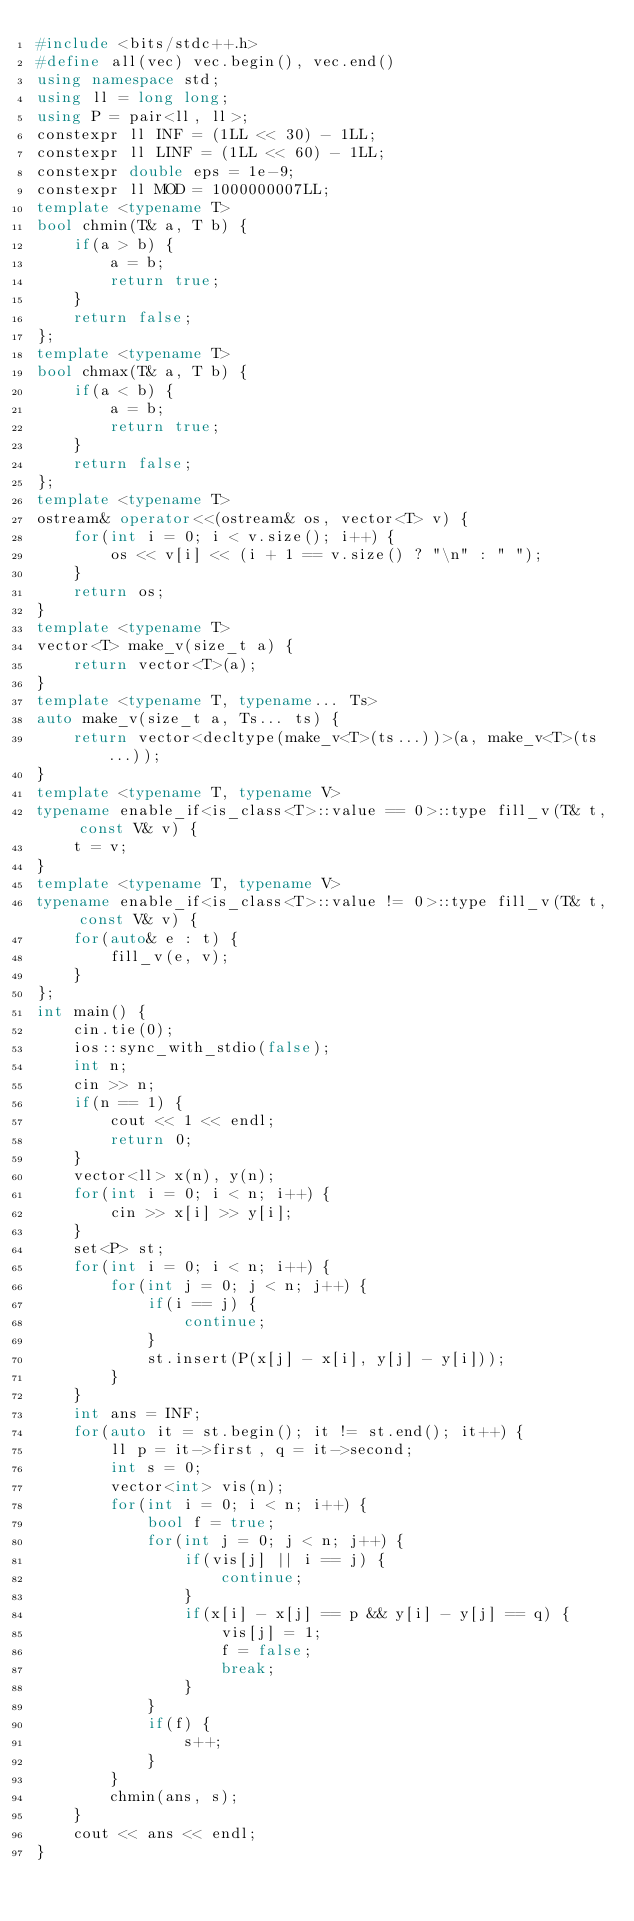Convert code to text. <code><loc_0><loc_0><loc_500><loc_500><_C++_>#include <bits/stdc++.h>
#define all(vec) vec.begin(), vec.end()
using namespace std;
using ll = long long;
using P = pair<ll, ll>;
constexpr ll INF = (1LL << 30) - 1LL;
constexpr ll LINF = (1LL << 60) - 1LL;
constexpr double eps = 1e-9;
constexpr ll MOD = 1000000007LL;
template <typename T>
bool chmin(T& a, T b) {
    if(a > b) {
        a = b;
        return true;
    }
    return false;
};
template <typename T>
bool chmax(T& a, T b) {
    if(a < b) {
        a = b;
        return true;
    }
    return false;
};
template <typename T>
ostream& operator<<(ostream& os, vector<T> v) {
    for(int i = 0; i < v.size(); i++) {
        os << v[i] << (i + 1 == v.size() ? "\n" : " ");
    }
    return os;
}
template <typename T>
vector<T> make_v(size_t a) {
    return vector<T>(a);
}
template <typename T, typename... Ts>
auto make_v(size_t a, Ts... ts) {
    return vector<decltype(make_v<T>(ts...))>(a, make_v<T>(ts...));
}
template <typename T, typename V>
typename enable_if<is_class<T>::value == 0>::type fill_v(T& t, const V& v) {
    t = v;
}
template <typename T, typename V>
typename enable_if<is_class<T>::value != 0>::type fill_v(T& t, const V& v) {
    for(auto& e : t) {
        fill_v(e, v);
    }
};
int main() {
    cin.tie(0);
    ios::sync_with_stdio(false);
    int n;
    cin >> n;
    if(n == 1) {
        cout << 1 << endl;
        return 0;
    }
    vector<ll> x(n), y(n);
    for(int i = 0; i < n; i++) {
        cin >> x[i] >> y[i];
    }
    set<P> st;
    for(int i = 0; i < n; i++) {
        for(int j = 0; j < n; j++) {
            if(i == j) {
                continue;
            }
            st.insert(P(x[j] - x[i], y[j] - y[i]));
        }
    }
    int ans = INF;
    for(auto it = st.begin(); it != st.end(); it++) {
        ll p = it->first, q = it->second;
        int s = 0;
        vector<int> vis(n);
        for(int i = 0; i < n; i++) {
            bool f = true;
            for(int j = 0; j < n; j++) {
                if(vis[j] || i == j) {
                    continue;
                }
                if(x[i] - x[j] == p && y[i] - y[j] == q) {
                    vis[j] = 1;
                    f = false;
                    break;
                }
            }
            if(f) {
                s++;
            }
        }
        chmin(ans, s);
    }
    cout << ans << endl;
}
</code> 